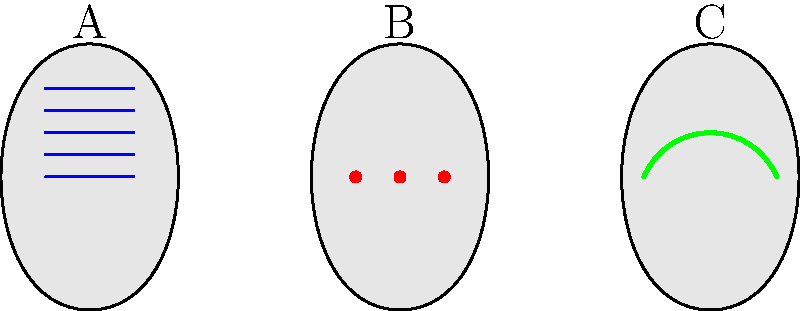As a senior conservator, you are training a new pottery restoration specialist. You show them the image above featuring three pottery samples (A, B, and C) with different surface decorations. Which of these samples exhibits the incised decoration technique? To answer this question, we need to analyze the surface decoration techniques shown on each pottery sample:

1. Sample A: This sample shows horizontal parallel lines in blue. These lines appear to be on the surface of the pottery, suggesting they were applied rather than cut into the clay. This technique is known as painted decoration.

2. Sample B: This sample displays a series of red dots on the surface. These dots were likely applied to the surface of the pottery using pigment or slip. This technique is called painted or applied decoration.

3. Sample C: This sample features a single curved line in green. The line appears to be cut or carved into the surface of the pottery rather than applied on top. This technique, where designs are created by cutting or carving into the clay surface before firing, is known as incised decoration.

Incised decoration is characterized by lines or patterns that are cut or carved into the clay surface before the pottery is fired. This technique creates a permanent alteration to the surface of the pottery, as opposed to painted or applied decorations which sit on top of the surface.

Given the characteristics of each sample, the pottery exhibiting the incised decoration technique is Sample C.
Answer: Sample C 